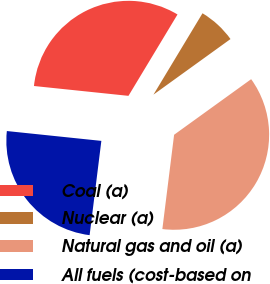Convert chart. <chart><loc_0><loc_0><loc_500><loc_500><pie_chart><fcel>Coal (a)<fcel>Nuclear (a)<fcel>Natural gas and oil (a)<fcel>All fuels (cost-based on<nl><fcel>31.98%<fcel>6.42%<fcel>36.92%<fcel>24.68%<nl></chart> 